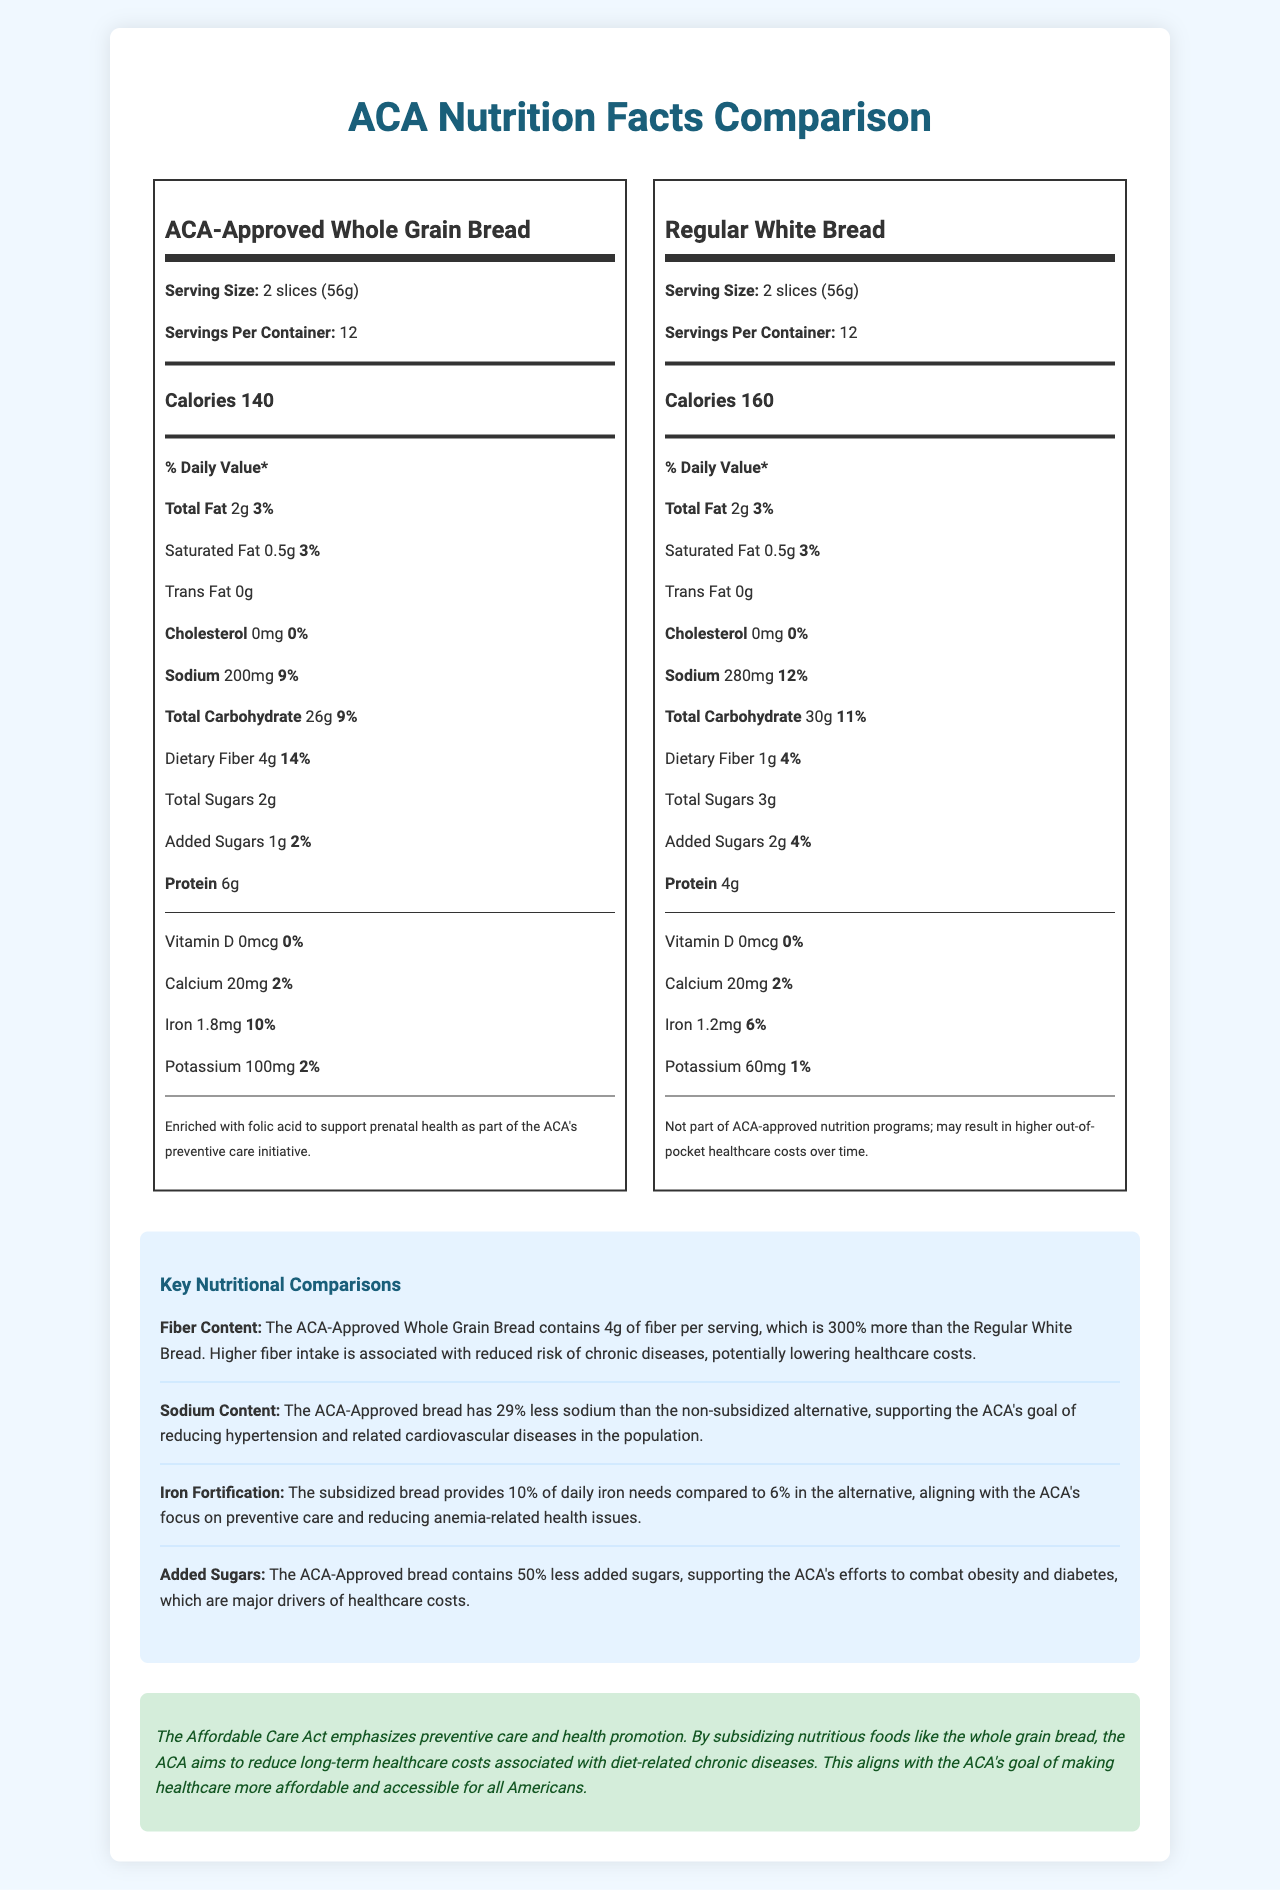what is the serving size of the ACA-Approved Whole Grain Bread? The serving size is clearly indicated as "2 slices (56g)" for the ACA-Approved Whole Grain Bread.
Answer: 2 slices (56g) how many calories are in one serving of Regular White Bread? The calories per serving for Regular White Bread are listed as 160.
Answer: 160 calories which type of bread has a higher fiber content? The ACA-Approved Whole Grain Bread contains 4g of fiber per serving, compared to 1g in the Regular White Bread.
Answer: ACA-Approved Whole Grain Bread how much sodium is in one serving of ACA-Approved Whole Grain Bread? The sodium content for one serving of ACA-Approved Whole Grain Bread is listed as 200mg.
Answer: 200mg what percentage of daily iron needs does the subsidized bread provide? The subsidized bread provides 10% of the daily iron needs.
Answer: 10% which bread has more added sugars per serving? A. ACA-Approved Whole Grain Bread B. Regular White Bread Regular White Bread contains 2g of added sugars per serving, whereas ACA-Approved Whole Grain Bread contains only 1g.
Answer: B which of the following nutritional aspects is not included in the ACA-Approved Whole Grain Bread label? A. Total Sugars B. Saturated Fat C. Vitamin C D. Protein Vitamin C is not listed on the nutrition label for ACA-Approved Whole Grain Bread.
Answer: C does the ACA-Approved Whole Grain Bread contain cholesterol? The document indicates that the cholesterol content is 0mg for the ACA-Approved Whole Grain Bread.
Answer: No summarize the main objective of the document. The document provides detailed nutritional information for both types of bread, emphasizes key differences in fiber, sodium, iron, and added sugars content, and explains how these differences contribute to health benefits aligned with ACA initiatives.
Answer: The document compares the nutritional content of ACA-Approved Whole Grain Bread with a non-subsidized alternative, Regular White Bread. It highlights how the ACA-subsidized bread aligns with the Affordable Care Act's goals of promoting preventive care and reducing long-term healthcare costs through better nutrition. what was the cost of the subsidized bread? The document does not provide any information regarding the cost of the ACA-Approved Whole Grain Bread.
Answer: Not enough information 